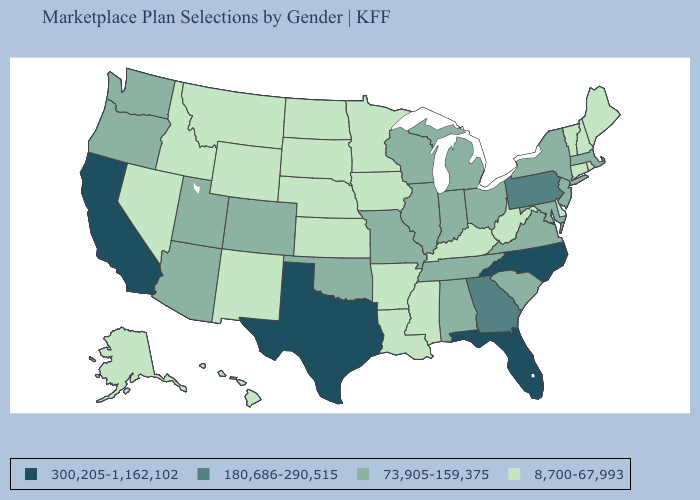What is the value of Louisiana?
Short answer required. 8,700-67,993. What is the lowest value in states that border Iowa?
Answer briefly. 8,700-67,993. Among the states that border South Carolina , which have the highest value?
Answer briefly. North Carolina. Name the states that have a value in the range 300,205-1,162,102?
Write a very short answer. California, Florida, North Carolina, Texas. Among the states that border New Hampshire , which have the lowest value?
Give a very brief answer. Maine, Vermont. What is the value of Idaho?
Concise answer only. 8,700-67,993. What is the highest value in the West ?
Write a very short answer. 300,205-1,162,102. Does California have the highest value in the USA?
Short answer required. Yes. Name the states that have a value in the range 73,905-159,375?
Short answer required. Alabama, Arizona, Colorado, Illinois, Indiana, Maryland, Massachusetts, Michigan, Missouri, New Jersey, New York, Ohio, Oklahoma, Oregon, South Carolina, Tennessee, Utah, Virginia, Washington, Wisconsin. Among the states that border Louisiana , which have the highest value?
Concise answer only. Texas. Name the states that have a value in the range 300,205-1,162,102?
Answer briefly. California, Florida, North Carolina, Texas. Does Texas have the lowest value in the USA?
Give a very brief answer. No. What is the highest value in the USA?
Keep it brief. 300,205-1,162,102. Among the states that border New Mexico , does Texas have the highest value?
Concise answer only. Yes. Which states have the lowest value in the South?
Answer briefly. Arkansas, Delaware, Kentucky, Louisiana, Mississippi, West Virginia. 